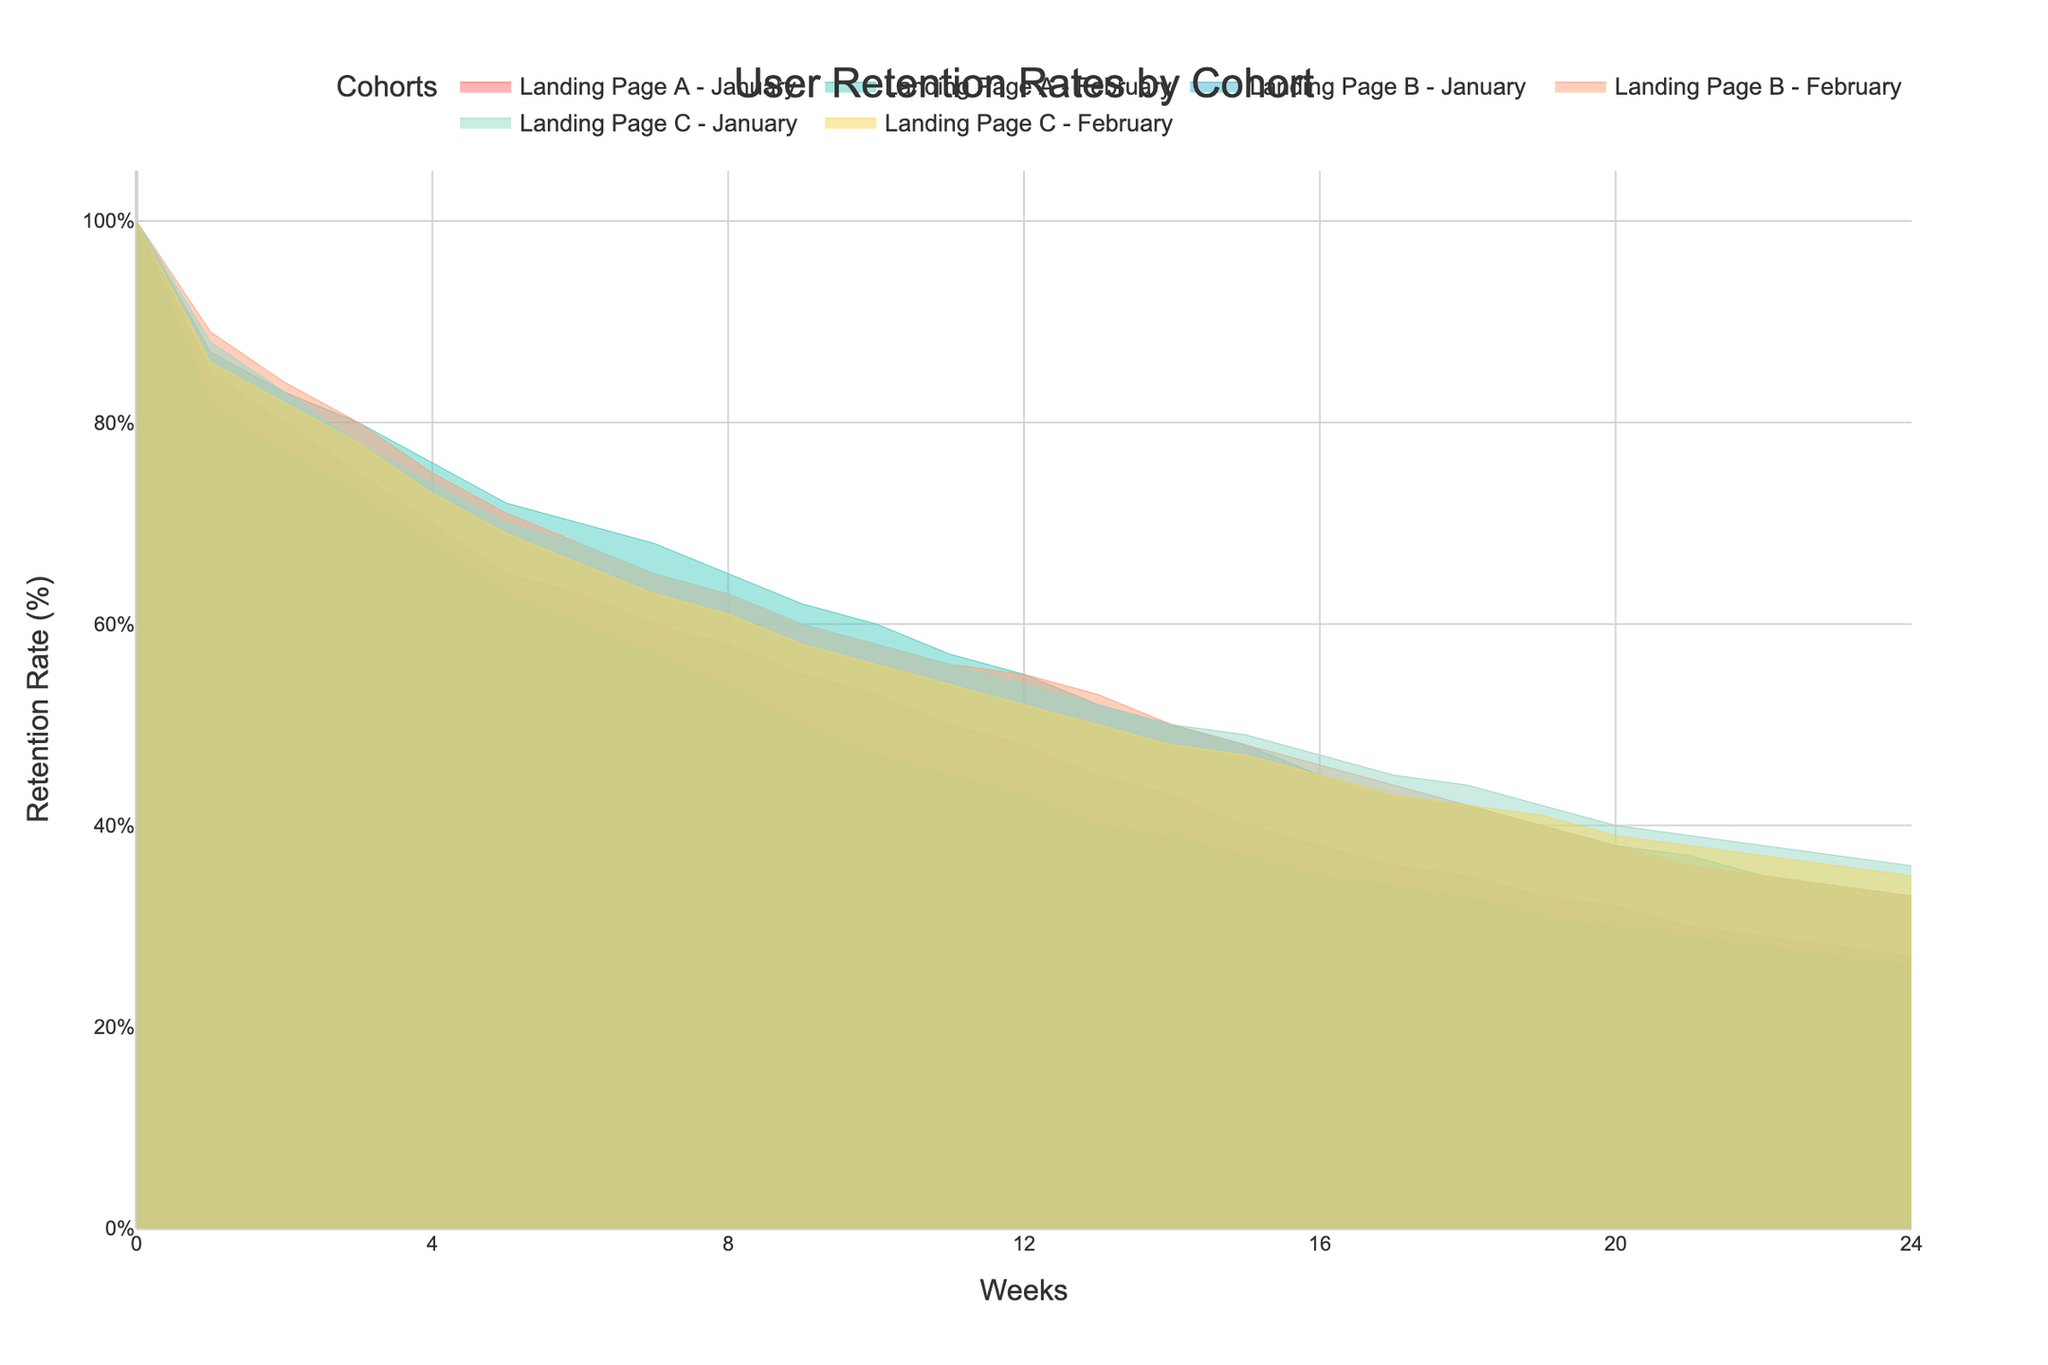What is the title of the figure? Look at the top center of the figure where the text is displayed in a larger font size. The title is 'User Retention Rates by Cohort'.
Answer: User Retention Rates by Cohort What is the retention rate for "Landing Page A - January" at Week 10? Locate the line corresponding to "Landing Page A - January" and find the value on the y-axis where Week 10 on the x-axis intersects this line. It shows that the retention rate at Week 10 is 50%.
Answer: 50% Between "Landing Page A - February" and "Landing Page B - February," which one has a higher retention rate at Week 6? Compare the y-values of each line at Week 6. "Landing Page A - February" has a retention rate of 72%, while "Landing Page B - February" has 68%. Hence, "Landing Page A - February" has a higher retention rate at Week 6.
Answer: Landing Page A - February Do any cohorts have the same retention rate at any week beyond Week 15? Observe the graph for points where two lines intersect beyond Week 15. For instance, "Landing Page A - January" and "Landing Page B - February" both have a retention rate of 33% at Week 19.
Answer: Yes What's the difference in retention rates between "Landing Page C - January" and "Landing Page A - January" at Week 12? At Week 12, "Landing Page C - January" has a retention rate of 54% and "Landing Page A - January" has 48%. The difference is 54% - 48% = 6%.
Answer: 6% Which cohort has the highest retention rate drop from Week 0 to Week 4? Calculate the drop by subtracting the Week 4 retention rate from the Week 0 rate for each cohort. "Landing Page B - January" has the largest drop from 100% to 68%, a 32% drop.
Answer: Landing Page B - January Which linear trend (growth or decline) is most visible in the plot? All cohorts are on a decline; compare the steepness. "Landing Page B - January" shows the steepest decline, indicating it has the most visible linear trend of decline.
Answer: Decline How do retention rates for "Landing Page C - January" and "Landing Page C - February" compare overall? Compare the lines across all weeks. Both have similar retention rates but "Landing Page C - January" starts slightly higher and maintains slightly higher retention up to Week 24.
Answer: "Landing Page C - January" is slightly higher How many weeks are plotted on the x-axis? Check the x-axis range, which starts from Week 0 and ends at Week 24. Counting starts from 0, giving us 25 weeks in total.
Answer: 25 weeks 